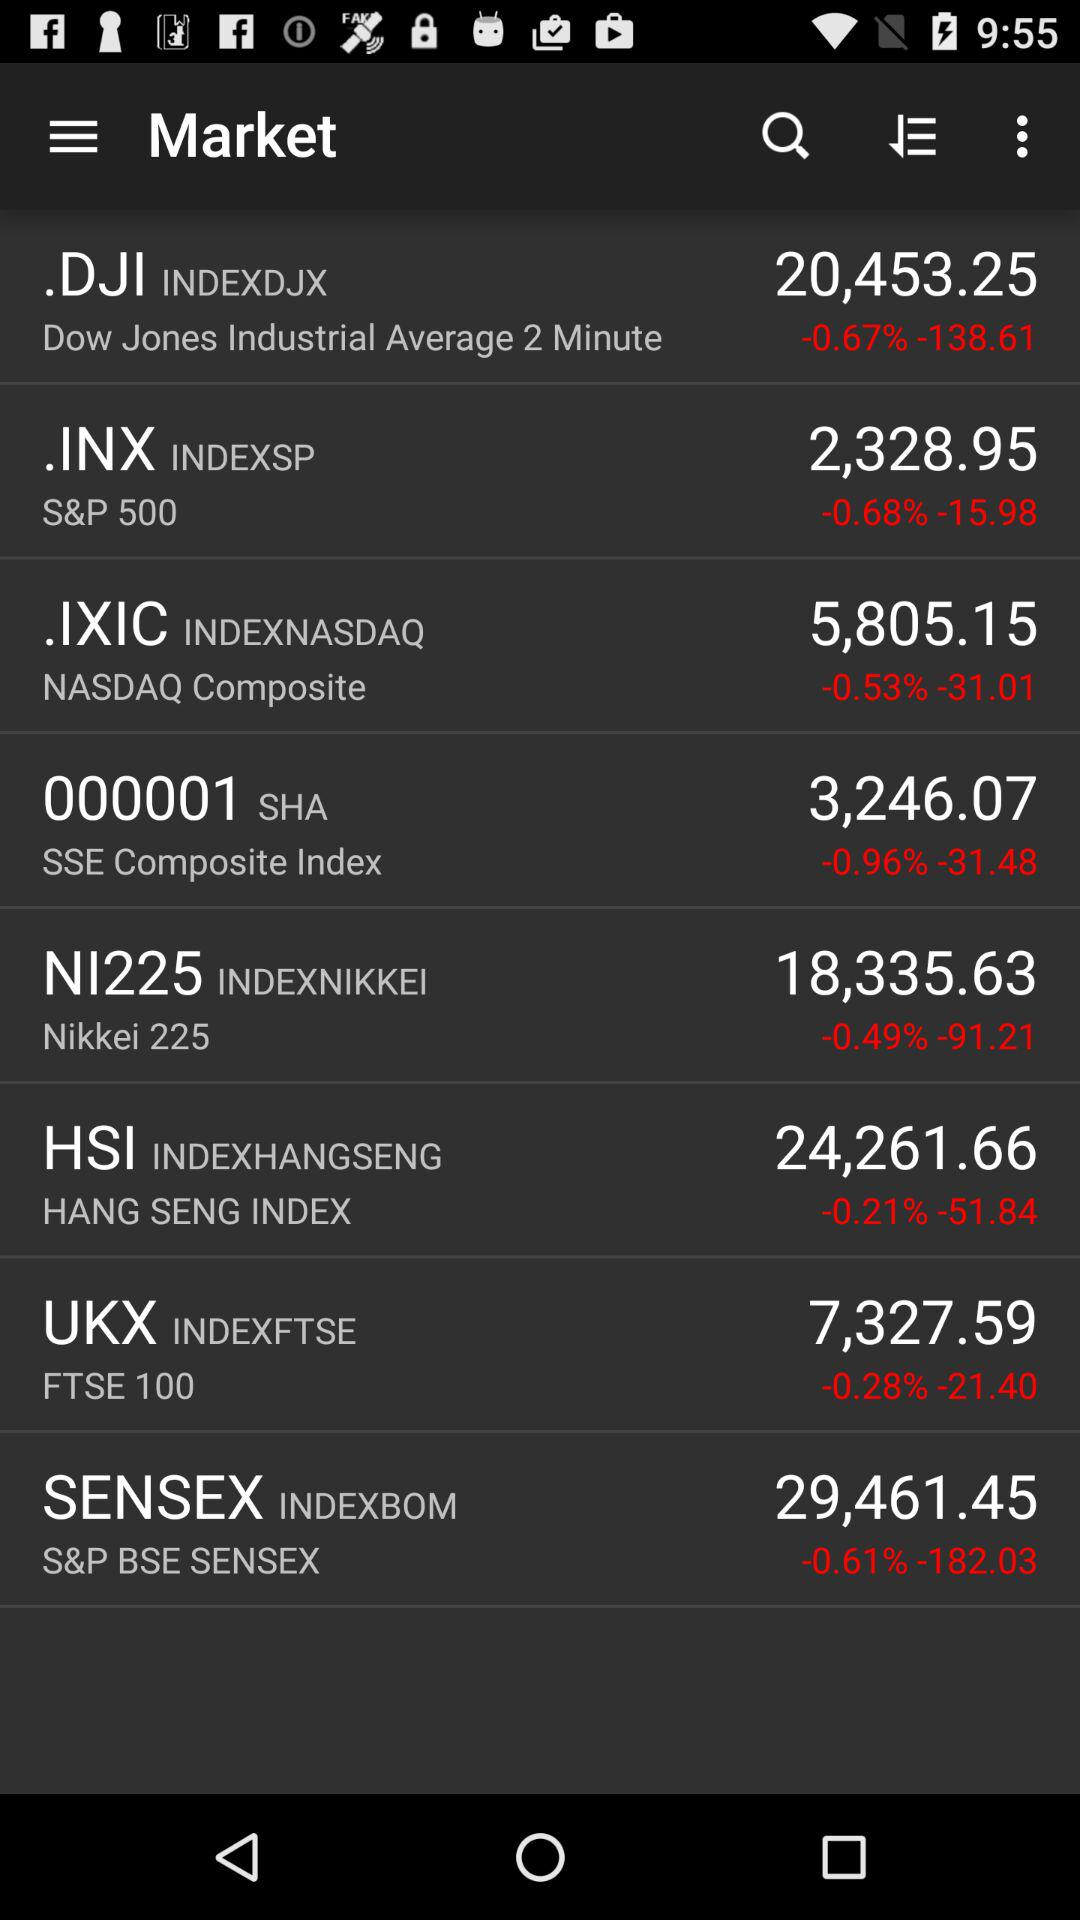Which market index has a greater change in value in absolute terms, NASDAQ Composite or S&P 500?
Answer the question using a single word or phrase. NASDAQ Composite 